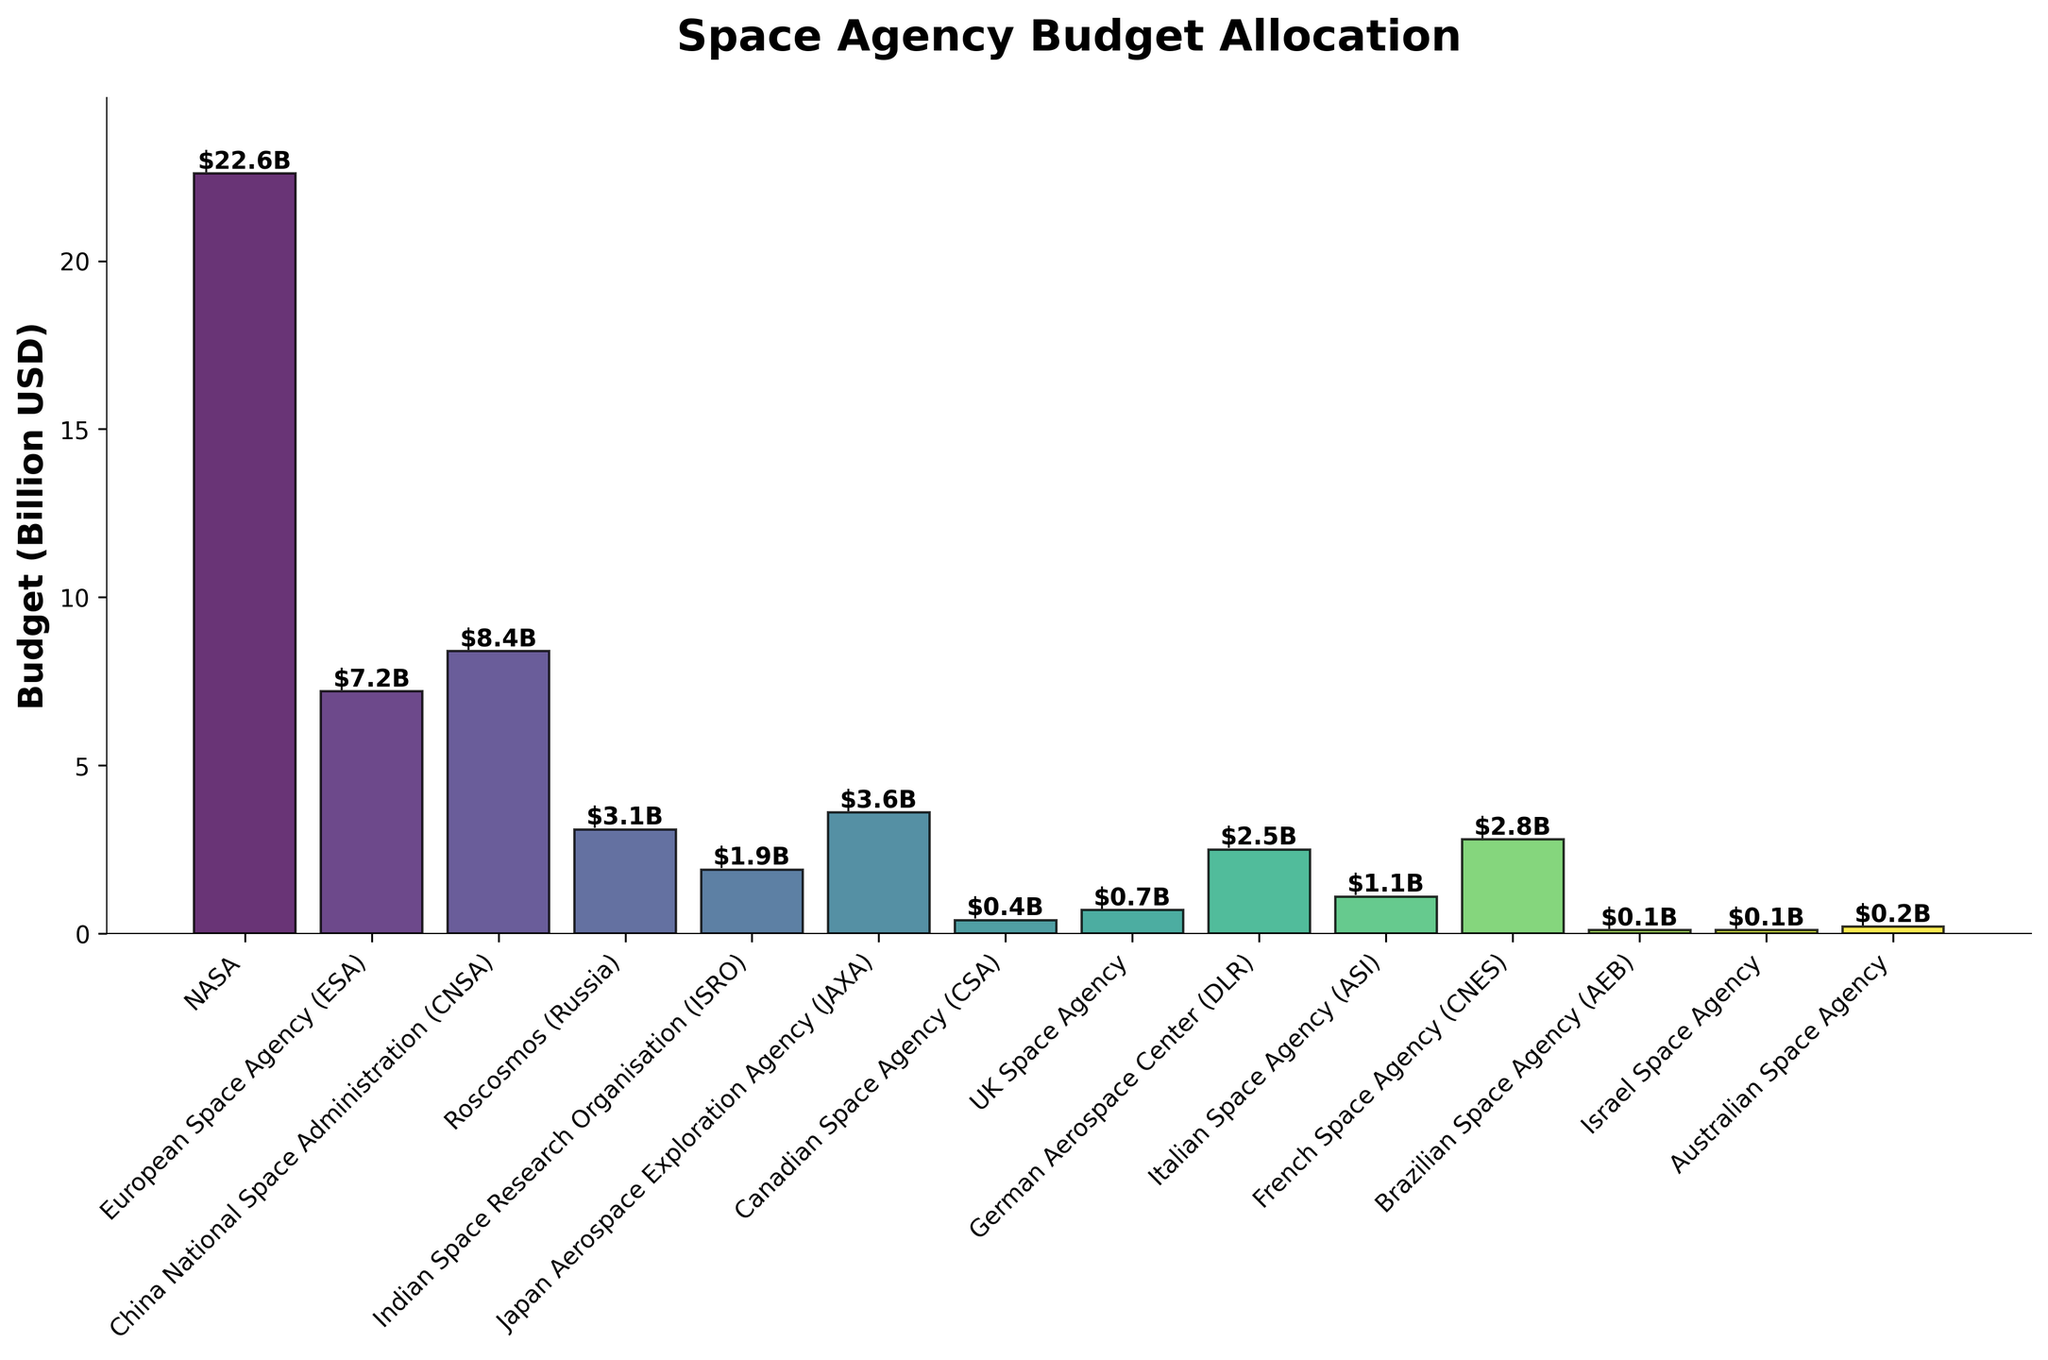Which space agency has the largest budget? The height of the bars visually represents the budget allocation. By comparing the heights, NASA's bar is the tallest among all, indicating that NASA has the largest budget.
Answer: NASA What is the total budget of the European Space Agency (ESA) and the China National Space Administration (CNSA)? To find the total, sum the two budgets: ESA's budget is $7.2B and CNSA's budget is $8.4B. So, $7.2B + $8.4B = $15.6B.
Answer: $15.6B Which space agencies have a budget less than $1 billion? By examining the heights of the bars and their corresponding labels, the agencies with budgets less than $1B are Canadian Space Agency (CSA) with $0.4B, UK Space Agency with $0.7B, Brazilian Space Agency (AEB) with $0.1B, Israel Space Agency with $0.1B, and Australian Space Agency with $0.2B.
Answer: Canadian Space Agency, UK Space Agency, Brazilian Space Agency, Israel Space Agency, Australian Space Agency How does the budget of the Japanese Aerospace Exploration Agency (JAXA) compare to Roscosmos? By comparing the heights of the bars for JAXA and Roscosmos, JAXA's budget is represented as $3.6B, which is higher than Roscosmos's $3.1B.
Answer: JAXA's budget is higher What is the combined budget of all agencies? Calculate the sum of all individual budgets: $22.6B (NASA) + $7.2B (ESA) + $8.4B (CNSA) + $3.1B (Roscosmos) + $1.9B (ISRO) + $3.6B (JAXA) + $0.4B (CSA) + $0.7B (UK Space Agency) + $2.5B (DLR) + $1.1B (ASI) + $2.8B (CNES) + $0.1B (AEB) + $0.1B (Israel Space Agency) + $0.2B (Australian Space Agency) = $54.7 billion.
Answer: $54.7 billion How much more is NASA's budget compared to the Indian Space Research Organisation (ISRO)? Subtract ISRO's budget from NASA's budget: $22.6B - $1.9B = $20.7B.
Answer: $20.7 billion Which Space Agency has the second smallest budget? By examining the heights of the bars sorted in ascending order, the second smallest budget is $0.2B, corresponding to the Australian Space Agency.
Answer: Australian Space Agency What is the average budget of the top five agencies? Identify the top five agencies by budget: NASA ($22.6B), CNSA ($8.4B), ESA ($7.2B), JAXA ($3.6B), and Roscosmos ($3.1B). Sum their budgets and divide by 5: ($22.6B + $8.4B + $7.2B + $3.6B + $3.1B) / 5 = $44.9B / 5 = $8.98B.
Answer: $8.98 billion 